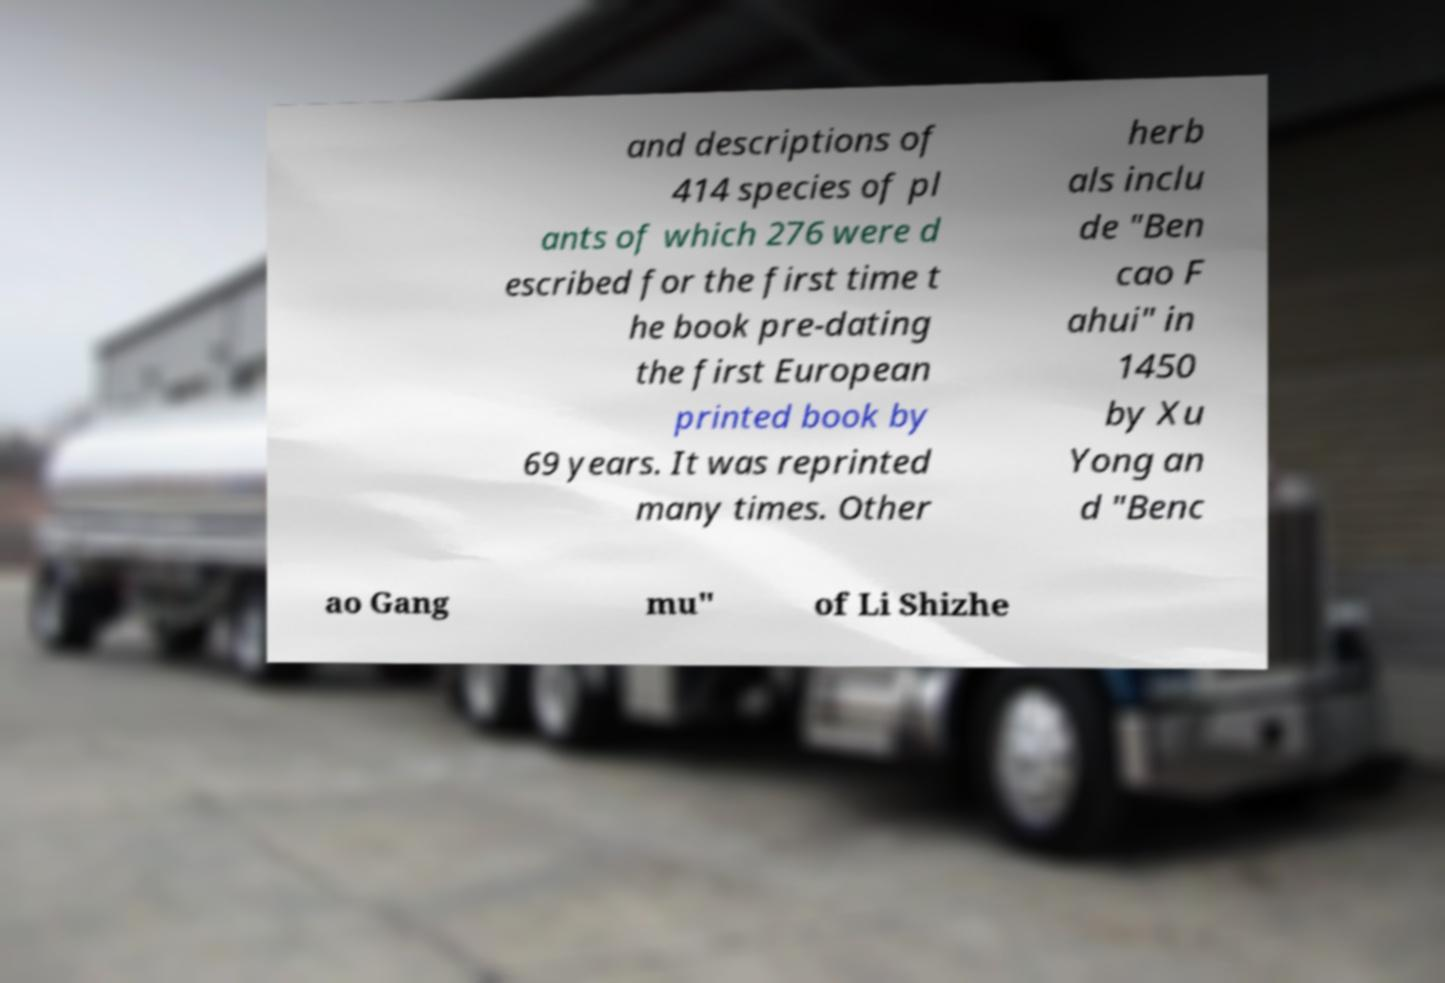Please read and relay the text visible in this image. What does it say? and descriptions of 414 species of pl ants of which 276 were d escribed for the first time t he book pre-dating the first European printed book by 69 years. It was reprinted many times. Other herb als inclu de "Ben cao F ahui" in 1450 by Xu Yong an d "Benc ao Gang mu" of Li Shizhe 